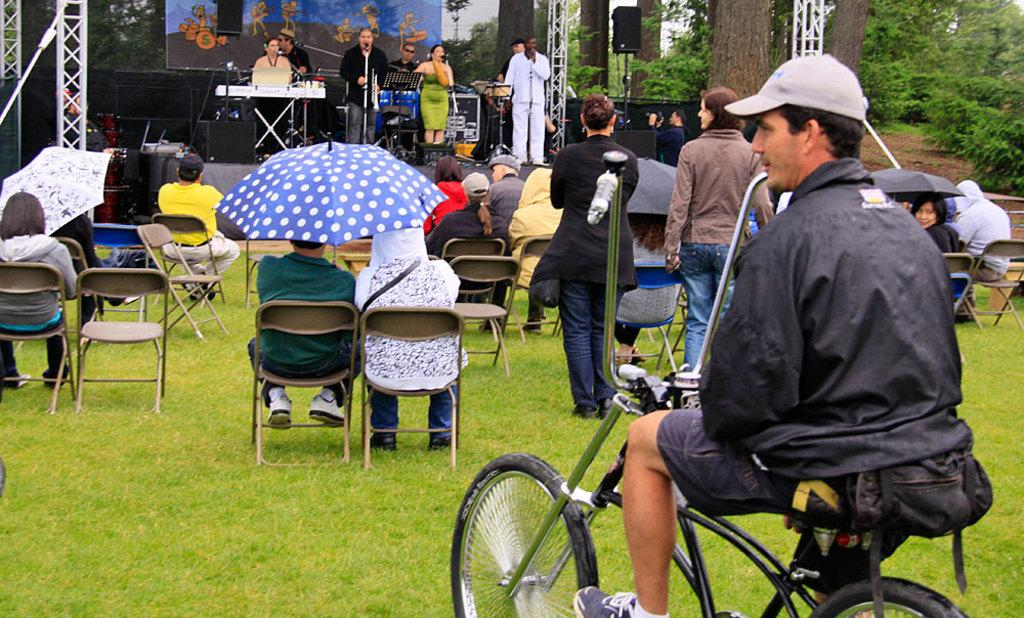How many people are in the image? There are many people in the image. What are the people doing in the image? Some people are sitting, while others are standing. What type of surface is visible in the image? There is grass visible in the image. What object can be seen in the image that is used for transportation? There is a bicycle in the image. What type of headwear is worn by some people in the image? Some people are wearing caps. What structure is present in the image that might be used for performances? There is a stage in the image. What type of vegetation is present in the image? Trees are present in the image. How many times do the people attempt to lip sync in the image? There is no indication in the image that the people are attempting to lip sync, so it cannot be determined from the picture. 